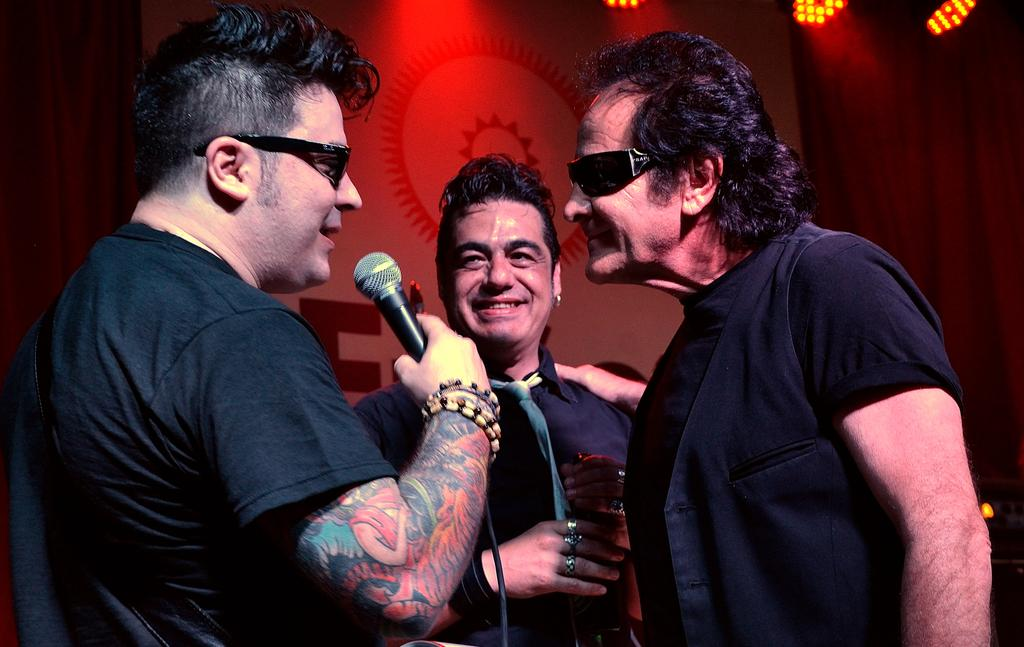How many people are in the image? There are three persons standing in the image. What are the expressions on their faces? The persons are smiling in the image. What can be seen in the background of the image? There is a hoarding and focus lights in the background of the image. What is the rate of the iron in the image? There is no iron present in the image, so it is not possible to determine its rate. 